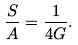<formula> <loc_0><loc_0><loc_500><loc_500>\frac { S } { A } = \frac { 1 } { 4 G } .</formula> 